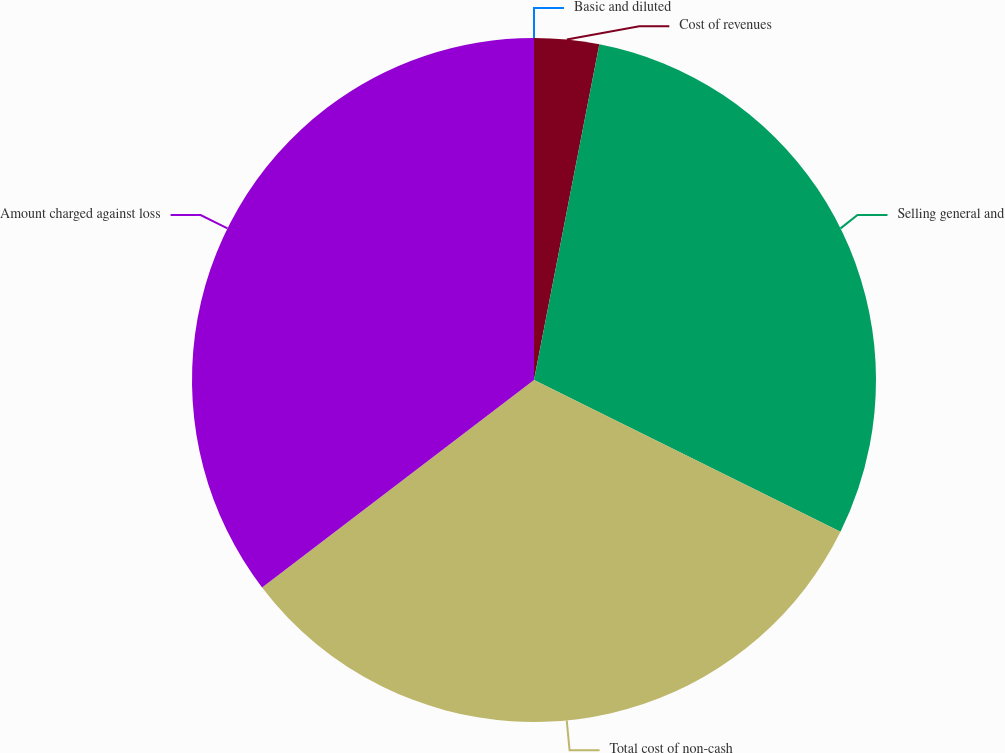Convert chart. <chart><loc_0><loc_0><loc_500><loc_500><pie_chart><fcel>Cost of revenues<fcel>Selling general and<fcel>Total cost of non-cash<fcel>Amount charged against loss<fcel>Basic and diluted<nl><fcel>3.06%<fcel>29.26%<fcel>32.31%<fcel>35.37%<fcel>0.0%<nl></chart> 